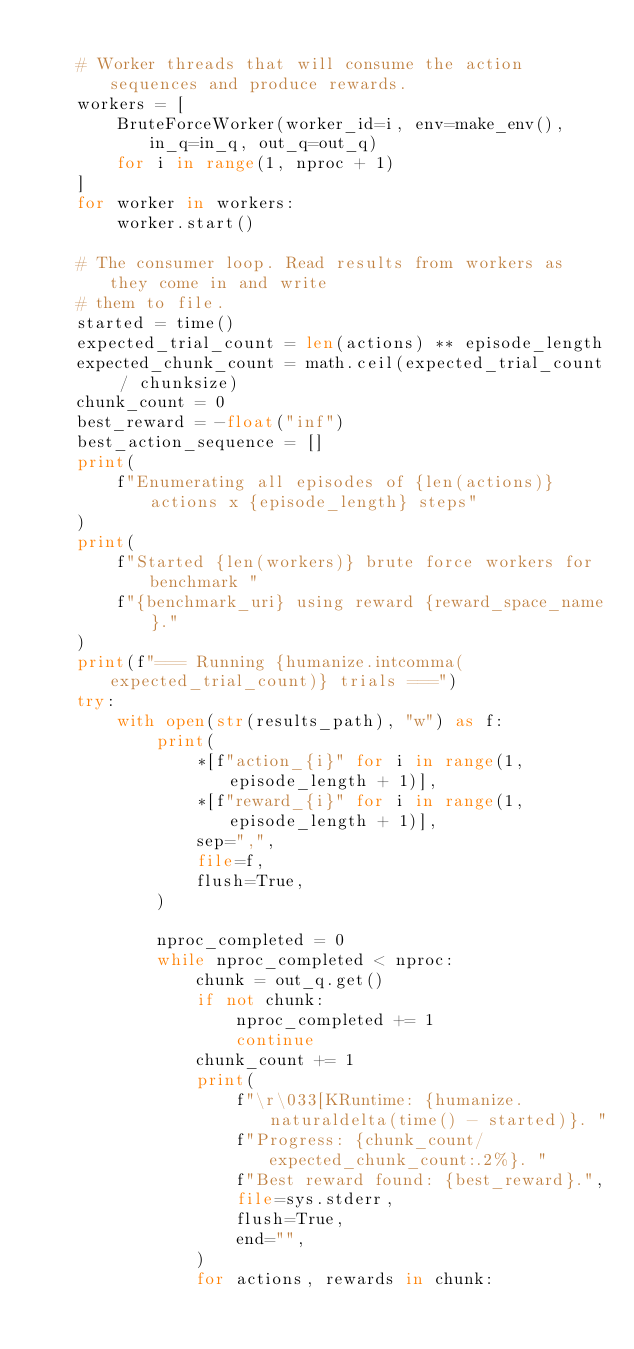Convert code to text. <code><loc_0><loc_0><loc_500><loc_500><_Python_>
    # Worker threads that will consume the action sequences and produce rewards.
    workers = [
        BruteForceWorker(worker_id=i, env=make_env(), in_q=in_q, out_q=out_q)
        for i in range(1, nproc + 1)
    ]
    for worker in workers:
        worker.start()

    # The consumer loop. Read results from workers as they come in and write
    # them to file.
    started = time()
    expected_trial_count = len(actions) ** episode_length
    expected_chunk_count = math.ceil(expected_trial_count / chunksize)
    chunk_count = 0
    best_reward = -float("inf")
    best_action_sequence = []
    print(
        f"Enumerating all episodes of {len(actions)} actions x {episode_length} steps"
    )
    print(
        f"Started {len(workers)} brute force workers for benchmark "
        f"{benchmark_uri} using reward {reward_space_name}."
    )
    print(f"=== Running {humanize.intcomma(expected_trial_count)} trials ===")
    try:
        with open(str(results_path), "w") as f:
            print(
                *[f"action_{i}" for i in range(1, episode_length + 1)],
                *[f"reward_{i}" for i in range(1, episode_length + 1)],
                sep=",",
                file=f,
                flush=True,
            )

            nproc_completed = 0
            while nproc_completed < nproc:
                chunk = out_q.get()
                if not chunk:
                    nproc_completed += 1
                    continue
                chunk_count += 1
                print(
                    f"\r\033[KRuntime: {humanize.naturaldelta(time() - started)}. "
                    f"Progress: {chunk_count/expected_chunk_count:.2%}. "
                    f"Best reward found: {best_reward}.",
                    file=sys.stderr,
                    flush=True,
                    end="",
                )
                for actions, rewards in chunk:</code> 